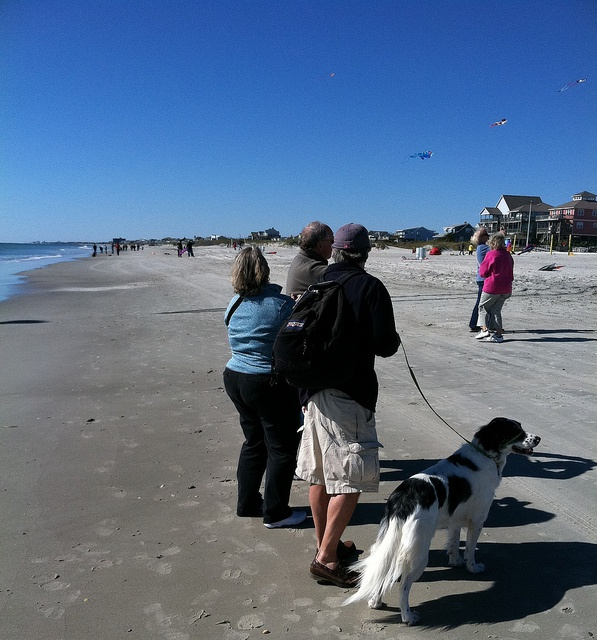Describe the objects in this image and their specific colors. I can see people in blue, black, gray, darkgray, and lightgray tones, dog in blue, black, gray, white, and darkblue tones, people in blue, black, and gray tones, backpack in blue, black, gray, and darkgray tones, and people in blue, black, purple, darkgray, and gray tones in this image. 